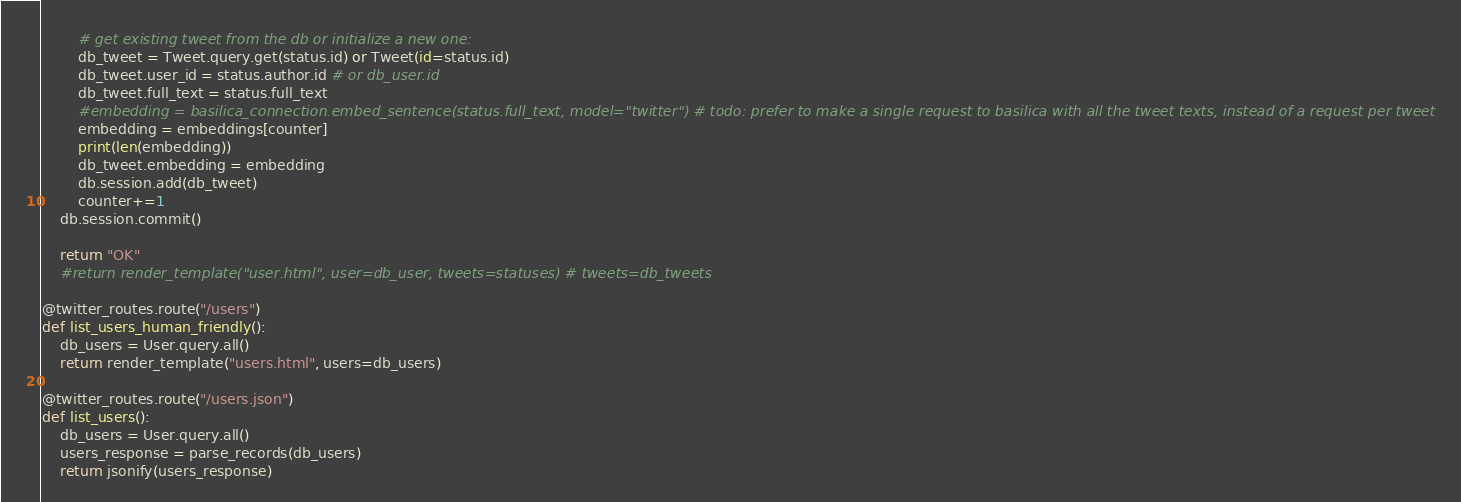Convert code to text. <code><loc_0><loc_0><loc_500><loc_500><_Python_>        # get existing tweet from the db or initialize a new one:
        db_tweet = Tweet.query.get(status.id) or Tweet(id=status.id)
        db_tweet.user_id = status.author.id # or db_user.id
        db_tweet.full_text = status.full_text
        #embedding = basilica_connection.embed_sentence(status.full_text, model="twitter") # todo: prefer to make a single request to basilica with all the tweet texts, instead of a request per tweet
        embedding = embeddings[counter]
        print(len(embedding))
        db_tweet.embedding = embedding
        db.session.add(db_tweet)
        counter+=1
    db.session.commit()

    return "OK"
    #return render_template("user.html", user=db_user, tweets=statuses) # tweets=db_tweets

@twitter_routes.route("/users")
def list_users_human_friendly():
    db_users = User.query.all()
    return render_template("users.html", users=db_users)

@twitter_routes.route("/users.json")
def list_users():
    db_users = User.query.all()
    users_response = parse_records(db_users)
    return jsonify(users_response)
</code> 